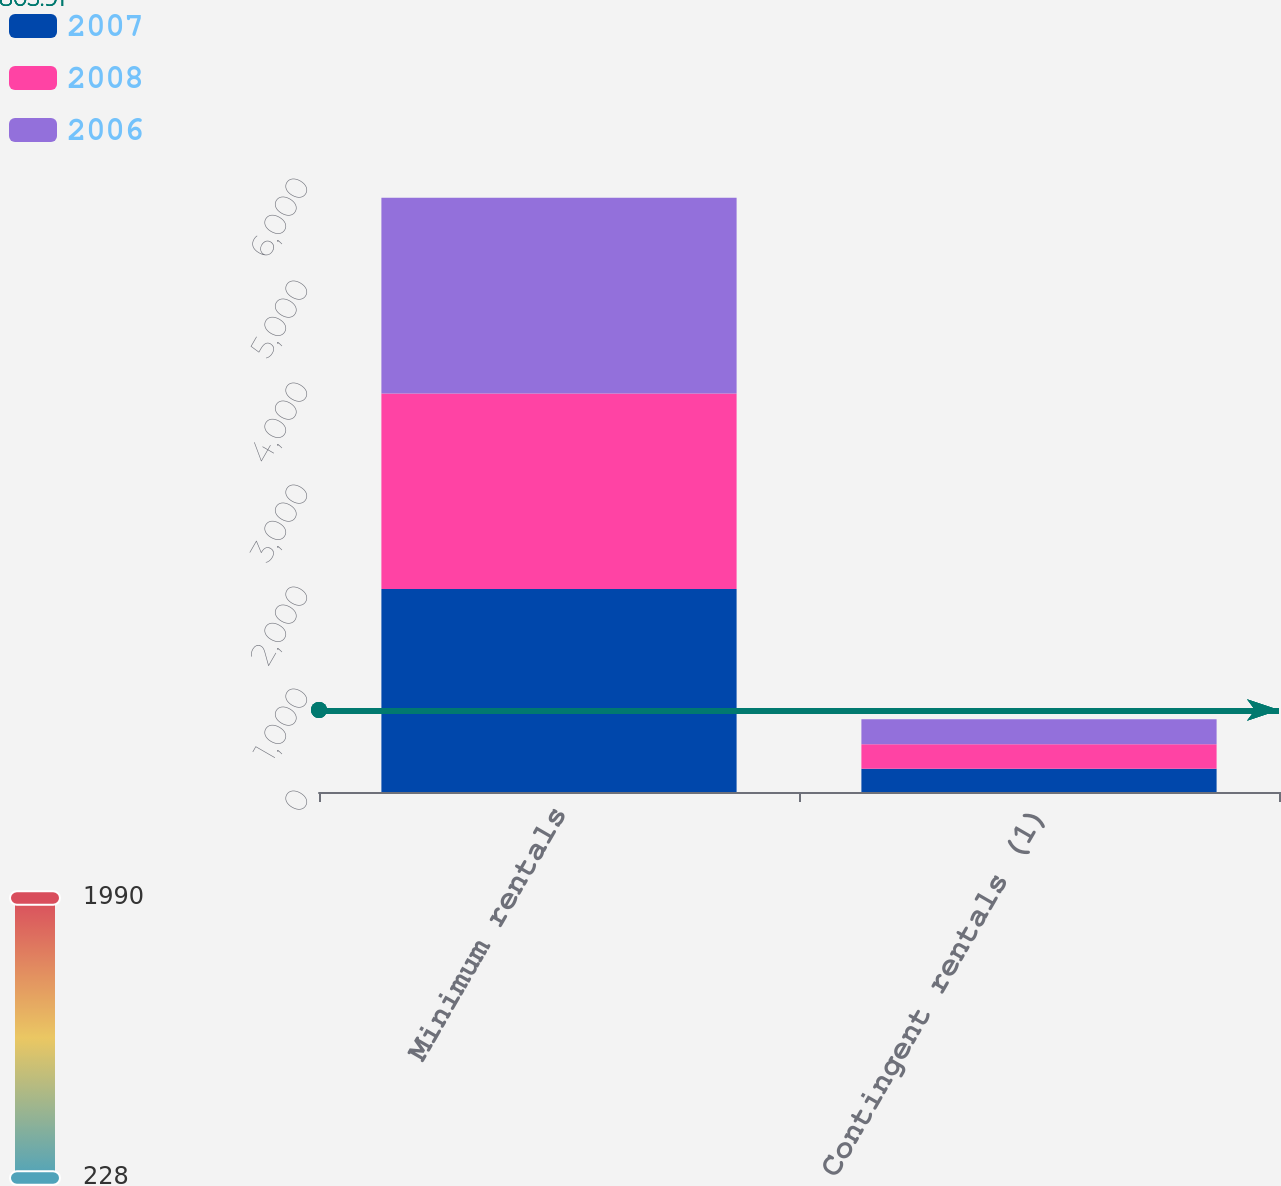<chart> <loc_0><loc_0><loc_500><loc_500><stacked_bar_chart><ecel><fcel>Minimum rentals<fcel>Contingent rentals (1)<nl><fcel>2007<fcel>1990<fcel>228<nl><fcel>2008<fcel>1916<fcel>241<nl><fcel>2006<fcel>1919<fcel>245<nl></chart> 